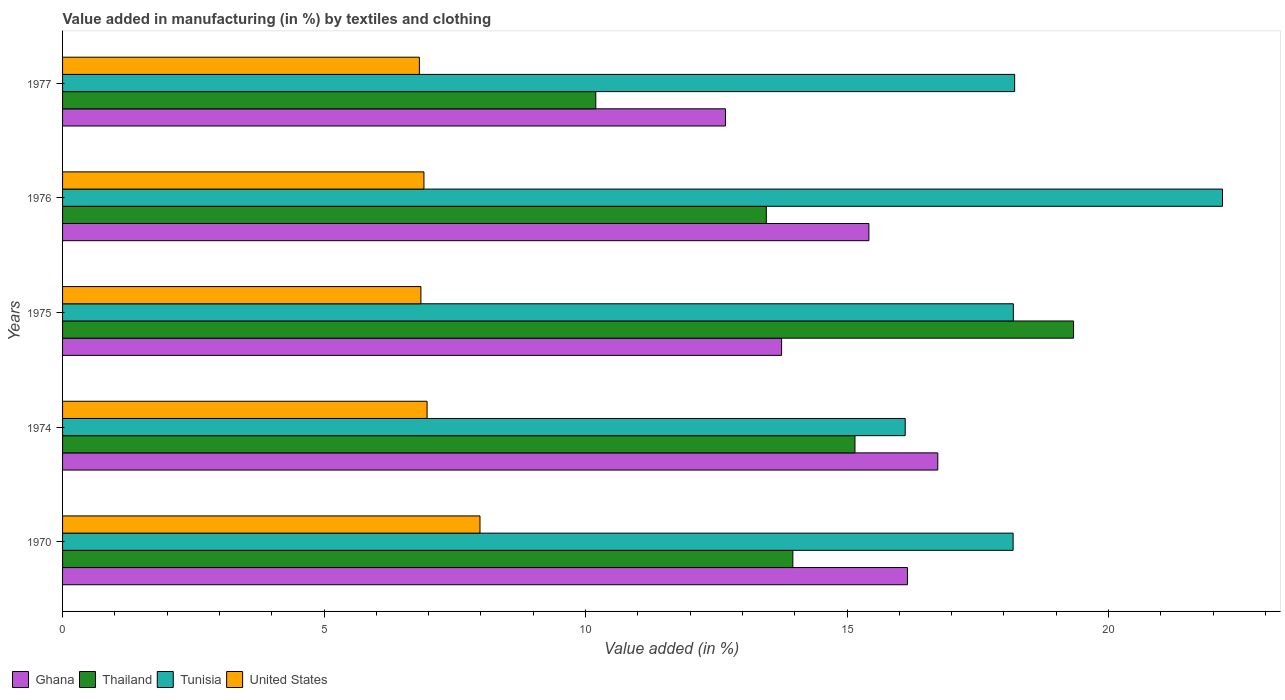How many different coloured bars are there?
Keep it short and to the point. 4. Are the number of bars per tick equal to the number of legend labels?
Provide a short and direct response. Yes. Are the number of bars on each tick of the Y-axis equal?
Your answer should be very brief. Yes. How many bars are there on the 2nd tick from the bottom?
Keep it short and to the point. 4. In how many cases, is the number of bars for a given year not equal to the number of legend labels?
Provide a succinct answer. 0. What is the percentage of value added in manufacturing by textiles and clothing in Ghana in 1974?
Make the answer very short. 16.73. Across all years, what is the maximum percentage of value added in manufacturing by textiles and clothing in Thailand?
Your answer should be very brief. 19.33. Across all years, what is the minimum percentage of value added in manufacturing by textiles and clothing in Tunisia?
Make the answer very short. 16.11. In which year was the percentage of value added in manufacturing by textiles and clothing in Ghana maximum?
Give a very brief answer. 1974. In which year was the percentage of value added in manufacturing by textiles and clothing in Tunisia minimum?
Give a very brief answer. 1974. What is the total percentage of value added in manufacturing by textiles and clothing in Thailand in the graph?
Offer a terse response. 72.1. What is the difference between the percentage of value added in manufacturing by textiles and clothing in Ghana in 1975 and that in 1976?
Offer a very short reply. -1.67. What is the difference between the percentage of value added in manufacturing by textiles and clothing in Thailand in 1975 and the percentage of value added in manufacturing by textiles and clothing in Ghana in 1976?
Make the answer very short. 3.91. What is the average percentage of value added in manufacturing by textiles and clothing in United States per year?
Offer a very short reply. 7.11. In the year 1975, what is the difference between the percentage of value added in manufacturing by textiles and clothing in Tunisia and percentage of value added in manufacturing by textiles and clothing in Ghana?
Provide a short and direct response. 4.43. In how many years, is the percentage of value added in manufacturing by textiles and clothing in Ghana greater than 1 %?
Your answer should be compact. 5. What is the ratio of the percentage of value added in manufacturing by textiles and clothing in Thailand in 1970 to that in 1974?
Offer a very short reply. 0.92. Is the percentage of value added in manufacturing by textiles and clothing in Tunisia in 1974 less than that in 1977?
Provide a short and direct response. Yes. Is the difference between the percentage of value added in manufacturing by textiles and clothing in Tunisia in 1970 and 1975 greater than the difference between the percentage of value added in manufacturing by textiles and clothing in Ghana in 1970 and 1975?
Ensure brevity in your answer.  No. What is the difference between the highest and the second highest percentage of value added in manufacturing by textiles and clothing in Tunisia?
Your answer should be compact. 3.97. What is the difference between the highest and the lowest percentage of value added in manufacturing by textiles and clothing in Ghana?
Your response must be concise. 4.06. In how many years, is the percentage of value added in manufacturing by textiles and clothing in Tunisia greater than the average percentage of value added in manufacturing by textiles and clothing in Tunisia taken over all years?
Give a very brief answer. 1. Is it the case that in every year, the sum of the percentage of value added in manufacturing by textiles and clothing in Tunisia and percentage of value added in manufacturing by textiles and clothing in Ghana is greater than the sum of percentage of value added in manufacturing by textiles and clothing in Thailand and percentage of value added in manufacturing by textiles and clothing in United States?
Your response must be concise. Yes. What does the 1st bar from the top in 1977 represents?
Keep it short and to the point. United States. How many years are there in the graph?
Your answer should be compact. 5. What is the difference between two consecutive major ticks on the X-axis?
Offer a terse response. 5. Are the values on the major ticks of X-axis written in scientific E-notation?
Offer a terse response. No. Does the graph contain any zero values?
Offer a terse response. No. Does the graph contain grids?
Your answer should be compact. No. How are the legend labels stacked?
Your answer should be very brief. Horizontal. What is the title of the graph?
Your answer should be very brief. Value added in manufacturing (in %) by textiles and clothing. What is the label or title of the X-axis?
Ensure brevity in your answer.  Value added (in %). What is the label or title of the Y-axis?
Offer a very short reply. Years. What is the Value added (in %) of Ghana in 1970?
Offer a terse response. 16.15. What is the Value added (in %) of Thailand in 1970?
Your answer should be compact. 13.96. What is the Value added (in %) in Tunisia in 1970?
Keep it short and to the point. 18.18. What is the Value added (in %) of United States in 1970?
Make the answer very short. 7.98. What is the Value added (in %) of Ghana in 1974?
Your answer should be compact. 16.73. What is the Value added (in %) of Thailand in 1974?
Provide a short and direct response. 15.15. What is the Value added (in %) in Tunisia in 1974?
Offer a terse response. 16.11. What is the Value added (in %) of United States in 1974?
Your response must be concise. 6.97. What is the Value added (in %) of Ghana in 1975?
Your response must be concise. 13.75. What is the Value added (in %) of Thailand in 1975?
Give a very brief answer. 19.33. What is the Value added (in %) of Tunisia in 1975?
Keep it short and to the point. 18.18. What is the Value added (in %) in United States in 1975?
Offer a very short reply. 6.85. What is the Value added (in %) in Ghana in 1976?
Offer a terse response. 15.42. What is the Value added (in %) in Thailand in 1976?
Your response must be concise. 13.46. What is the Value added (in %) of Tunisia in 1976?
Ensure brevity in your answer.  22.18. What is the Value added (in %) in United States in 1976?
Ensure brevity in your answer.  6.91. What is the Value added (in %) in Ghana in 1977?
Offer a very short reply. 12.68. What is the Value added (in %) of Thailand in 1977?
Give a very brief answer. 10.2. What is the Value added (in %) of Tunisia in 1977?
Your answer should be compact. 18.2. What is the Value added (in %) of United States in 1977?
Provide a succinct answer. 6.82. Across all years, what is the maximum Value added (in %) of Ghana?
Provide a succinct answer. 16.73. Across all years, what is the maximum Value added (in %) in Thailand?
Make the answer very short. 19.33. Across all years, what is the maximum Value added (in %) in Tunisia?
Keep it short and to the point. 22.18. Across all years, what is the maximum Value added (in %) of United States?
Offer a terse response. 7.98. Across all years, what is the minimum Value added (in %) of Ghana?
Provide a short and direct response. 12.68. Across all years, what is the minimum Value added (in %) of Thailand?
Ensure brevity in your answer.  10.2. Across all years, what is the minimum Value added (in %) of Tunisia?
Keep it short and to the point. 16.11. Across all years, what is the minimum Value added (in %) of United States?
Your response must be concise. 6.82. What is the total Value added (in %) in Ghana in the graph?
Your response must be concise. 74.73. What is the total Value added (in %) in Thailand in the graph?
Ensure brevity in your answer.  72.1. What is the total Value added (in %) in Tunisia in the graph?
Provide a succinct answer. 92.85. What is the total Value added (in %) of United States in the graph?
Keep it short and to the point. 35.53. What is the difference between the Value added (in %) of Ghana in 1970 and that in 1974?
Offer a very short reply. -0.58. What is the difference between the Value added (in %) in Thailand in 1970 and that in 1974?
Provide a short and direct response. -1.19. What is the difference between the Value added (in %) in Tunisia in 1970 and that in 1974?
Your answer should be very brief. 2.06. What is the difference between the Value added (in %) in United States in 1970 and that in 1974?
Offer a very short reply. 1.01. What is the difference between the Value added (in %) in Ghana in 1970 and that in 1975?
Offer a very short reply. 2.41. What is the difference between the Value added (in %) of Thailand in 1970 and that in 1975?
Ensure brevity in your answer.  -5.37. What is the difference between the Value added (in %) in Tunisia in 1970 and that in 1975?
Your answer should be very brief. -0. What is the difference between the Value added (in %) in United States in 1970 and that in 1975?
Your answer should be compact. 1.13. What is the difference between the Value added (in %) in Ghana in 1970 and that in 1976?
Make the answer very short. 0.74. What is the difference between the Value added (in %) of Thailand in 1970 and that in 1976?
Give a very brief answer. 0.51. What is the difference between the Value added (in %) in Tunisia in 1970 and that in 1976?
Make the answer very short. -4. What is the difference between the Value added (in %) in United States in 1970 and that in 1976?
Your answer should be very brief. 1.07. What is the difference between the Value added (in %) in Ghana in 1970 and that in 1977?
Your response must be concise. 3.48. What is the difference between the Value added (in %) in Thailand in 1970 and that in 1977?
Offer a very short reply. 3.77. What is the difference between the Value added (in %) of Tunisia in 1970 and that in 1977?
Keep it short and to the point. -0.03. What is the difference between the Value added (in %) of United States in 1970 and that in 1977?
Ensure brevity in your answer.  1.16. What is the difference between the Value added (in %) in Ghana in 1974 and that in 1975?
Your answer should be very brief. 2.99. What is the difference between the Value added (in %) of Thailand in 1974 and that in 1975?
Your answer should be very brief. -4.18. What is the difference between the Value added (in %) in Tunisia in 1974 and that in 1975?
Offer a terse response. -2.07. What is the difference between the Value added (in %) in United States in 1974 and that in 1975?
Offer a very short reply. 0.12. What is the difference between the Value added (in %) in Ghana in 1974 and that in 1976?
Provide a short and direct response. 1.32. What is the difference between the Value added (in %) of Thailand in 1974 and that in 1976?
Provide a succinct answer. 1.7. What is the difference between the Value added (in %) of Tunisia in 1974 and that in 1976?
Offer a very short reply. -6.07. What is the difference between the Value added (in %) in United States in 1974 and that in 1976?
Offer a terse response. 0.06. What is the difference between the Value added (in %) in Ghana in 1974 and that in 1977?
Provide a short and direct response. 4.06. What is the difference between the Value added (in %) of Thailand in 1974 and that in 1977?
Keep it short and to the point. 4.96. What is the difference between the Value added (in %) of Tunisia in 1974 and that in 1977?
Offer a very short reply. -2.09. What is the difference between the Value added (in %) of United States in 1974 and that in 1977?
Your answer should be compact. 0.15. What is the difference between the Value added (in %) of Ghana in 1975 and that in 1976?
Make the answer very short. -1.67. What is the difference between the Value added (in %) of Thailand in 1975 and that in 1976?
Offer a terse response. 5.87. What is the difference between the Value added (in %) of Tunisia in 1975 and that in 1976?
Your answer should be compact. -4. What is the difference between the Value added (in %) of United States in 1975 and that in 1976?
Your response must be concise. -0.06. What is the difference between the Value added (in %) in Ghana in 1975 and that in 1977?
Provide a succinct answer. 1.07. What is the difference between the Value added (in %) in Thailand in 1975 and that in 1977?
Your answer should be very brief. 9.14. What is the difference between the Value added (in %) in Tunisia in 1975 and that in 1977?
Your answer should be very brief. -0.02. What is the difference between the Value added (in %) in United States in 1975 and that in 1977?
Ensure brevity in your answer.  0.03. What is the difference between the Value added (in %) of Ghana in 1976 and that in 1977?
Your response must be concise. 2.74. What is the difference between the Value added (in %) in Thailand in 1976 and that in 1977?
Keep it short and to the point. 3.26. What is the difference between the Value added (in %) of Tunisia in 1976 and that in 1977?
Provide a succinct answer. 3.97. What is the difference between the Value added (in %) of United States in 1976 and that in 1977?
Offer a very short reply. 0.09. What is the difference between the Value added (in %) of Ghana in 1970 and the Value added (in %) of Thailand in 1974?
Offer a very short reply. 1. What is the difference between the Value added (in %) of Ghana in 1970 and the Value added (in %) of Tunisia in 1974?
Provide a succinct answer. 0.04. What is the difference between the Value added (in %) in Ghana in 1970 and the Value added (in %) in United States in 1974?
Give a very brief answer. 9.19. What is the difference between the Value added (in %) of Thailand in 1970 and the Value added (in %) of Tunisia in 1974?
Provide a short and direct response. -2.15. What is the difference between the Value added (in %) in Thailand in 1970 and the Value added (in %) in United States in 1974?
Provide a succinct answer. 6.99. What is the difference between the Value added (in %) in Tunisia in 1970 and the Value added (in %) in United States in 1974?
Provide a short and direct response. 11.21. What is the difference between the Value added (in %) of Ghana in 1970 and the Value added (in %) of Thailand in 1975?
Your answer should be compact. -3.18. What is the difference between the Value added (in %) in Ghana in 1970 and the Value added (in %) in Tunisia in 1975?
Your answer should be compact. -2.02. What is the difference between the Value added (in %) in Ghana in 1970 and the Value added (in %) in United States in 1975?
Give a very brief answer. 9.3. What is the difference between the Value added (in %) in Thailand in 1970 and the Value added (in %) in Tunisia in 1975?
Make the answer very short. -4.22. What is the difference between the Value added (in %) of Thailand in 1970 and the Value added (in %) of United States in 1975?
Your answer should be very brief. 7.11. What is the difference between the Value added (in %) of Tunisia in 1970 and the Value added (in %) of United States in 1975?
Give a very brief answer. 11.32. What is the difference between the Value added (in %) of Ghana in 1970 and the Value added (in %) of Thailand in 1976?
Keep it short and to the point. 2.7. What is the difference between the Value added (in %) in Ghana in 1970 and the Value added (in %) in Tunisia in 1976?
Keep it short and to the point. -6.02. What is the difference between the Value added (in %) in Ghana in 1970 and the Value added (in %) in United States in 1976?
Your answer should be compact. 9.24. What is the difference between the Value added (in %) in Thailand in 1970 and the Value added (in %) in Tunisia in 1976?
Provide a short and direct response. -8.21. What is the difference between the Value added (in %) of Thailand in 1970 and the Value added (in %) of United States in 1976?
Provide a succinct answer. 7.05. What is the difference between the Value added (in %) of Tunisia in 1970 and the Value added (in %) of United States in 1976?
Your answer should be very brief. 11.27. What is the difference between the Value added (in %) of Ghana in 1970 and the Value added (in %) of Thailand in 1977?
Offer a terse response. 5.96. What is the difference between the Value added (in %) in Ghana in 1970 and the Value added (in %) in Tunisia in 1977?
Provide a succinct answer. -2.05. What is the difference between the Value added (in %) of Ghana in 1970 and the Value added (in %) of United States in 1977?
Ensure brevity in your answer.  9.33. What is the difference between the Value added (in %) in Thailand in 1970 and the Value added (in %) in Tunisia in 1977?
Your response must be concise. -4.24. What is the difference between the Value added (in %) of Thailand in 1970 and the Value added (in %) of United States in 1977?
Your answer should be compact. 7.14. What is the difference between the Value added (in %) in Tunisia in 1970 and the Value added (in %) in United States in 1977?
Ensure brevity in your answer.  11.35. What is the difference between the Value added (in %) in Ghana in 1974 and the Value added (in %) in Thailand in 1975?
Offer a very short reply. -2.6. What is the difference between the Value added (in %) of Ghana in 1974 and the Value added (in %) of Tunisia in 1975?
Give a very brief answer. -1.44. What is the difference between the Value added (in %) of Ghana in 1974 and the Value added (in %) of United States in 1975?
Provide a short and direct response. 9.88. What is the difference between the Value added (in %) of Thailand in 1974 and the Value added (in %) of Tunisia in 1975?
Your answer should be very brief. -3.03. What is the difference between the Value added (in %) of Thailand in 1974 and the Value added (in %) of United States in 1975?
Give a very brief answer. 8.3. What is the difference between the Value added (in %) in Tunisia in 1974 and the Value added (in %) in United States in 1975?
Keep it short and to the point. 9.26. What is the difference between the Value added (in %) in Ghana in 1974 and the Value added (in %) in Thailand in 1976?
Offer a very short reply. 3.28. What is the difference between the Value added (in %) in Ghana in 1974 and the Value added (in %) in Tunisia in 1976?
Your answer should be very brief. -5.44. What is the difference between the Value added (in %) of Ghana in 1974 and the Value added (in %) of United States in 1976?
Keep it short and to the point. 9.83. What is the difference between the Value added (in %) of Thailand in 1974 and the Value added (in %) of Tunisia in 1976?
Provide a succinct answer. -7.03. What is the difference between the Value added (in %) in Thailand in 1974 and the Value added (in %) in United States in 1976?
Your answer should be very brief. 8.24. What is the difference between the Value added (in %) of Tunisia in 1974 and the Value added (in %) of United States in 1976?
Your response must be concise. 9.2. What is the difference between the Value added (in %) of Ghana in 1974 and the Value added (in %) of Thailand in 1977?
Ensure brevity in your answer.  6.54. What is the difference between the Value added (in %) in Ghana in 1974 and the Value added (in %) in Tunisia in 1977?
Ensure brevity in your answer.  -1.47. What is the difference between the Value added (in %) in Ghana in 1974 and the Value added (in %) in United States in 1977?
Keep it short and to the point. 9.91. What is the difference between the Value added (in %) of Thailand in 1974 and the Value added (in %) of Tunisia in 1977?
Your answer should be compact. -3.05. What is the difference between the Value added (in %) in Thailand in 1974 and the Value added (in %) in United States in 1977?
Offer a terse response. 8.33. What is the difference between the Value added (in %) of Tunisia in 1974 and the Value added (in %) of United States in 1977?
Your answer should be very brief. 9.29. What is the difference between the Value added (in %) of Ghana in 1975 and the Value added (in %) of Thailand in 1976?
Keep it short and to the point. 0.29. What is the difference between the Value added (in %) of Ghana in 1975 and the Value added (in %) of Tunisia in 1976?
Offer a very short reply. -8.43. What is the difference between the Value added (in %) of Ghana in 1975 and the Value added (in %) of United States in 1976?
Your response must be concise. 6.84. What is the difference between the Value added (in %) of Thailand in 1975 and the Value added (in %) of Tunisia in 1976?
Your response must be concise. -2.85. What is the difference between the Value added (in %) in Thailand in 1975 and the Value added (in %) in United States in 1976?
Keep it short and to the point. 12.42. What is the difference between the Value added (in %) in Tunisia in 1975 and the Value added (in %) in United States in 1976?
Your answer should be compact. 11.27. What is the difference between the Value added (in %) in Ghana in 1975 and the Value added (in %) in Thailand in 1977?
Provide a succinct answer. 3.55. What is the difference between the Value added (in %) in Ghana in 1975 and the Value added (in %) in Tunisia in 1977?
Your answer should be compact. -4.46. What is the difference between the Value added (in %) in Ghana in 1975 and the Value added (in %) in United States in 1977?
Offer a terse response. 6.93. What is the difference between the Value added (in %) in Thailand in 1975 and the Value added (in %) in Tunisia in 1977?
Give a very brief answer. 1.13. What is the difference between the Value added (in %) in Thailand in 1975 and the Value added (in %) in United States in 1977?
Offer a terse response. 12.51. What is the difference between the Value added (in %) in Tunisia in 1975 and the Value added (in %) in United States in 1977?
Ensure brevity in your answer.  11.36. What is the difference between the Value added (in %) in Ghana in 1976 and the Value added (in %) in Thailand in 1977?
Keep it short and to the point. 5.22. What is the difference between the Value added (in %) in Ghana in 1976 and the Value added (in %) in Tunisia in 1977?
Make the answer very short. -2.79. What is the difference between the Value added (in %) in Ghana in 1976 and the Value added (in %) in United States in 1977?
Your answer should be very brief. 8.6. What is the difference between the Value added (in %) in Thailand in 1976 and the Value added (in %) in Tunisia in 1977?
Your answer should be compact. -4.75. What is the difference between the Value added (in %) in Thailand in 1976 and the Value added (in %) in United States in 1977?
Provide a succinct answer. 6.63. What is the difference between the Value added (in %) in Tunisia in 1976 and the Value added (in %) in United States in 1977?
Make the answer very short. 15.36. What is the average Value added (in %) in Ghana per year?
Offer a terse response. 14.95. What is the average Value added (in %) in Thailand per year?
Give a very brief answer. 14.42. What is the average Value added (in %) of Tunisia per year?
Your answer should be compact. 18.57. What is the average Value added (in %) in United States per year?
Offer a terse response. 7.11. In the year 1970, what is the difference between the Value added (in %) in Ghana and Value added (in %) in Thailand?
Provide a succinct answer. 2.19. In the year 1970, what is the difference between the Value added (in %) of Ghana and Value added (in %) of Tunisia?
Give a very brief answer. -2.02. In the year 1970, what is the difference between the Value added (in %) in Ghana and Value added (in %) in United States?
Keep it short and to the point. 8.17. In the year 1970, what is the difference between the Value added (in %) in Thailand and Value added (in %) in Tunisia?
Give a very brief answer. -4.21. In the year 1970, what is the difference between the Value added (in %) of Thailand and Value added (in %) of United States?
Provide a short and direct response. 5.98. In the year 1970, what is the difference between the Value added (in %) in Tunisia and Value added (in %) in United States?
Offer a terse response. 10.19. In the year 1974, what is the difference between the Value added (in %) in Ghana and Value added (in %) in Thailand?
Offer a terse response. 1.58. In the year 1974, what is the difference between the Value added (in %) in Ghana and Value added (in %) in Tunisia?
Provide a short and direct response. 0.62. In the year 1974, what is the difference between the Value added (in %) of Ghana and Value added (in %) of United States?
Make the answer very short. 9.77. In the year 1974, what is the difference between the Value added (in %) in Thailand and Value added (in %) in Tunisia?
Provide a short and direct response. -0.96. In the year 1974, what is the difference between the Value added (in %) in Thailand and Value added (in %) in United States?
Your response must be concise. 8.18. In the year 1974, what is the difference between the Value added (in %) of Tunisia and Value added (in %) of United States?
Provide a succinct answer. 9.14. In the year 1975, what is the difference between the Value added (in %) of Ghana and Value added (in %) of Thailand?
Ensure brevity in your answer.  -5.58. In the year 1975, what is the difference between the Value added (in %) in Ghana and Value added (in %) in Tunisia?
Provide a short and direct response. -4.43. In the year 1975, what is the difference between the Value added (in %) in Ghana and Value added (in %) in United States?
Your answer should be compact. 6.9. In the year 1975, what is the difference between the Value added (in %) of Thailand and Value added (in %) of Tunisia?
Keep it short and to the point. 1.15. In the year 1975, what is the difference between the Value added (in %) of Thailand and Value added (in %) of United States?
Offer a terse response. 12.48. In the year 1975, what is the difference between the Value added (in %) in Tunisia and Value added (in %) in United States?
Make the answer very short. 11.33. In the year 1976, what is the difference between the Value added (in %) in Ghana and Value added (in %) in Thailand?
Provide a succinct answer. 1.96. In the year 1976, what is the difference between the Value added (in %) in Ghana and Value added (in %) in Tunisia?
Provide a short and direct response. -6.76. In the year 1976, what is the difference between the Value added (in %) in Ghana and Value added (in %) in United States?
Keep it short and to the point. 8.51. In the year 1976, what is the difference between the Value added (in %) in Thailand and Value added (in %) in Tunisia?
Provide a short and direct response. -8.72. In the year 1976, what is the difference between the Value added (in %) of Thailand and Value added (in %) of United States?
Your answer should be compact. 6.55. In the year 1976, what is the difference between the Value added (in %) of Tunisia and Value added (in %) of United States?
Provide a succinct answer. 15.27. In the year 1977, what is the difference between the Value added (in %) in Ghana and Value added (in %) in Thailand?
Your response must be concise. 2.48. In the year 1977, what is the difference between the Value added (in %) of Ghana and Value added (in %) of Tunisia?
Your response must be concise. -5.53. In the year 1977, what is the difference between the Value added (in %) in Ghana and Value added (in %) in United States?
Offer a terse response. 5.85. In the year 1977, what is the difference between the Value added (in %) in Thailand and Value added (in %) in Tunisia?
Offer a very short reply. -8.01. In the year 1977, what is the difference between the Value added (in %) of Thailand and Value added (in %) of United States?
Your answer should be compact. 3.37. In the year 1977, what is the difference between the Value added (in %) in Tunisia and Value added (in %) in United States?
Offer a very short reply. 11.38. What is the ratio of the Value added (in %) of Ghana in 1970 to that in 1974?
Keep it short and to the point. 0.97. What is the ratio of the Value added (in %) in Thailand in 1970 to that in 1974?
Give a very brief answer. 0.92. What is the ratio of the Value added (in %) in Tunisia in 1970 to that in 1974?
Provide a short and direct response. 1.13. What is the ratio of the Value added (in %) of United States in 1970 to that in 1974?
Keep it short and to the point. 1.15. What is the ratio of the Value added (in %) of Ghana in 1970 to that in 1975?
Make the answer very short. 1.18. What is the ratio of the Value added (in %) of Thailand in 1970 to that in 1975?
Provide a succinct answer. 0.72. What is the ratio of the Value added (in %) in Tunisia in 1970 to that in 1975?
Make the answer very short. 1. What is the ratio of the Value added (in %) of United States in 1970 to that in 1975?
Ensure brevity in your answer.  1.16. What is the ratio of the Value added (in %) of Ghana in 1970 to that in 1976?
Your response must be concise. 1.05. What is the ratio of the Value added (in %) in Thailand in 1970 to that in 1976?
Make the answer very short. 1.04. What is the ratio of the Value added (in %) of Tunisia in 1970 to that in 1976?
Give a very brief answer. 0.82. What is the ratio of the Value added (in %) of United States in 1970 to that in 1976?
Offer a very short reply. 1.16. What is the ratio of the Value added (in %) in Ghana in 1970 to that in 1977?
Keep it short and to the point. 1.27. What is the ratio of the Value added (in %) in Thailand in 1970 to that in 1977?
Provide a succinct answer. 1.37. What is the ratio of the Value added (in %) of Tunisia in 1970 to that in 1977?
Your response must be concise. 1. What is the ratio of the Value added (in %) of United States in 1970 to that in 1977?
Give a very brief answer. 1.17. What is the ratio of the Value added (in %) of Ghana in 1974 to that in 1975?
Your response must be concise. 1.22. What is the ratio of the Value added (in %) of Thailand in 1974 to that in 1975?
Ensure brevity in your answer.  0.78. What is the ratio of the Value added (in %) of Tunisia in 1974 to that in 1975?
Offer a terse response. 0.89. What is the ratio of the Value added (in %) in United States in 1974 to that in 1975?
Your answer should be very brief. 1.02. What is the ratio of the Value added (in %) of Ghana in 1974 to that in 1976?
Provide a short and direct response. 1.09. What is the ratio of the Value added (in %) of Thailand in 1974 to that in 1976?
Make the answer very short. 1.13. What is the ratio of the Value added (in %) of Tunisia in 1974 to that in 1976?
Your answer should be compact. 0.73. What is the ratio of the Value added (in %) in United States in 1974 to that in 1976?
Provide a short and direct response. 1.01. What is the ratio of the Value added (in %) of Ghana in 1974 to that in 1977?
Your answer should be compact. 1.32. What is the ratio of the Value added (in %) of Thailand in 1974 to that in 1977?
Make the answer very short. 1.49. What is the ratio of the Value added (in %) of Tunisia in 1974 to that in 1977?
Offer a terse response. 0.89. What is the ratio of the Value added (in %) in United States in 1974 to that in 1977?
Keep it short and to the point. 1.02. What is the ratio of the Value added (in %) in Ghana in 1975 to that in 1976?
Offer a terse response. 0.89. What is the ratio of the Value added (in %) in Thailand in 1975 to that in 1976?
Provide a short and direct response. 1.44. What is the ratio of the Value added (in %) in Tunisia in 1975 to that in 1976?
Offer a very short reply. 0.82. What is the ratio of the Value added (in %) in Ghana in 1975 to that in 1977?
Your answer should be very brief. 1.08. What is the ratio of the Value added (in %) of Thailand in 1975 to that in 1977?
Offer a terse response. 1.9. What is the ratio of the Value added (in %) in Tunisia in 1975 to that in 1977?
Make the answer very short. 1. What is the ratio of the Value added (in %) of United States in 1975 to that in 1977?
Provide a short and direct response. 1. What is the ratio of the Value added (in %) of Ghana in 1976 to that in 1977?
Keep it short and to the point. 1.22. What is the ratio of the Value added (in %) in Thailand in 1976 to that in 1977?
Your answer should be very brief. 1.32. What is the ratio of the Value added (in %) of Tunisia in 1976 to that in 1977?
Provide a short and direct response. 1.22. What is the ratio of the Value added (in %) of United States in 1976 to that in 1977?
Your answer should be very brief. 1.01. What is the difference between the highest and the second highest Value added (in %) of Ghana?
Give a very brief answer. 0.58. What is the difference between the highest and the second highest Value added (in %) of Thailand?
Provide a succinct answer. 4.18. What is the difference between the highest and the second highest Value added (in %) in Tunisia?
Keep it short and to the point. 3.97. What is the difference between the highest and the second highest Value added (in %) of United States?
Ensure brevity in your answer.  1.01. What is the difference between the highest and the lowest Value added (in %) in Ghana?
Your answer should be compact. 4.06. What is the difference between the highest and the lowest Value added (in %) of Thailand?
Your response must be concise. 9.14. What is the difference between the highest and the lowest Value added (in %) of Tunisia?
Your answer should be very brief. 6.07. What is the difference between the highest and the lowest Value added (in %) of United States?
Provide a short and direct response. 1.16. 